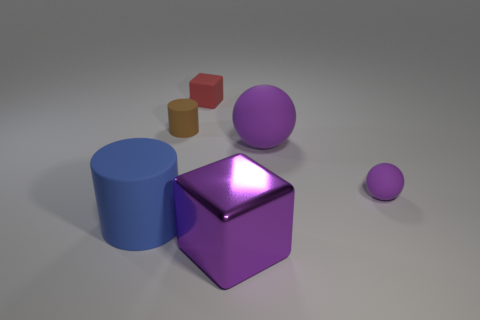There is a object on the left side of the brown thing; is its shape the same as the large purple matte thing?
Offer a terse response. No. There is a sphere in front of the large matte ball; what is it made of?
Keep it short and to the point. Rubber. How many matte objects are big purple objects or brown spheres?
Make the answer very short. 1. Is there a thing that has the same size as the metallic cube?
Ensure brevity in your answer.  Yes. Is the number of tiny purple matte spheres behind the big rubber ball greater than the number of large red cylinders?
Provide a short and direct response. No. How many big objects are red rubber things or blue cylinders?
Provide a succinct answer. 1. What number of small purple matte things are the same shape as the large purple metallic object?
Your answer should be very brief. 0. What material is the purple sphere behind the purple rubber object right of the large sphere?
Make the answer very short. Rubber. There is a purple matte ball behind the tiny purple rubber object; how big is it?
Keep it short and to the point. Large. How many brown things are small rubber spheres or large objects?
Your response must be concise. 0. 